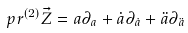Convert formula to latex. <formula><loc_0><loc_0><loc_500><loc_500>p r ^ { ( 2 ) } \vec { Z } = a \partial _ { a } + \dot { a } \partial _ { \dot { a } } + \ddot { a } \partial _ { \ddot { a } }</formula> 